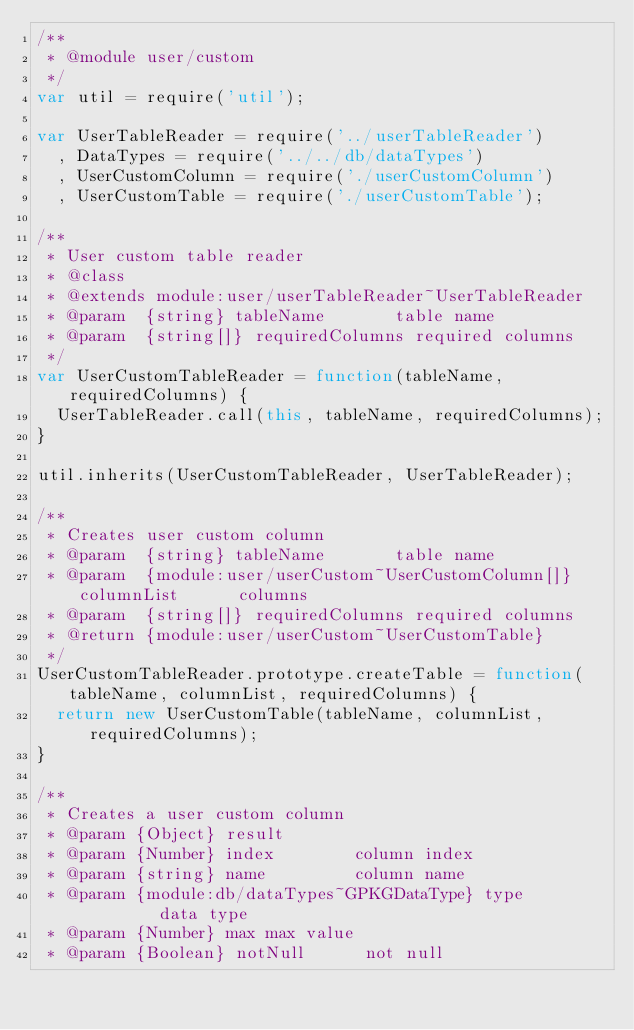<code> <loc_0><loc_0><loc_500><loc_500><_JavaScript_>/**
 * @module user/custom
 */
var util = require('util');

var UserTableReader = require('../userTableReader')
  , DataTypes = require('../../db/dataTypes')
  , UserCustomColumn = require('./userCustomColumn')
  , UserCustomTable = require('./userCustomTable');

/**
 * User custom table reader
 * @class
 * @extends module:user/userTableReader~UserTableReader
 * @param  {string} tableName       table name
 * @param  {string[]} requiredColumns required columns
 */
var UserCustomTableReader = function(tableName, requiredColumns) {
  UserTableReader.call(this, tableName, requiredColumns);
}

util.inherits(UserCustomTableReader, UserTableReader);

/**
 * Creates user custom column
 * @param  {string} tableName       table name
 * @param  {module:user/userCustom~UserCustomColumn[]} columnList      columns
 * @param  {string[]} requiredColumns required columns
 * @return {module:user/userCustom~UserCustomTable}
 */
UserCustomTableReader.prototype.createTable = function(tableName, columnList, requiredColumns) {
  return new UserCustomTable(tableName, columnList, requiredColumns);
}

/**
 * Creates a user custom column
 * @param {Object} result
 * @param {Number} index        column index
 * @param {string} name         column name
 * @param {module:db/dataTypes~GPKGDataType} type         data type
 * @param {Number} max max value
 * @param {Boolean} notNull      not null</code> 